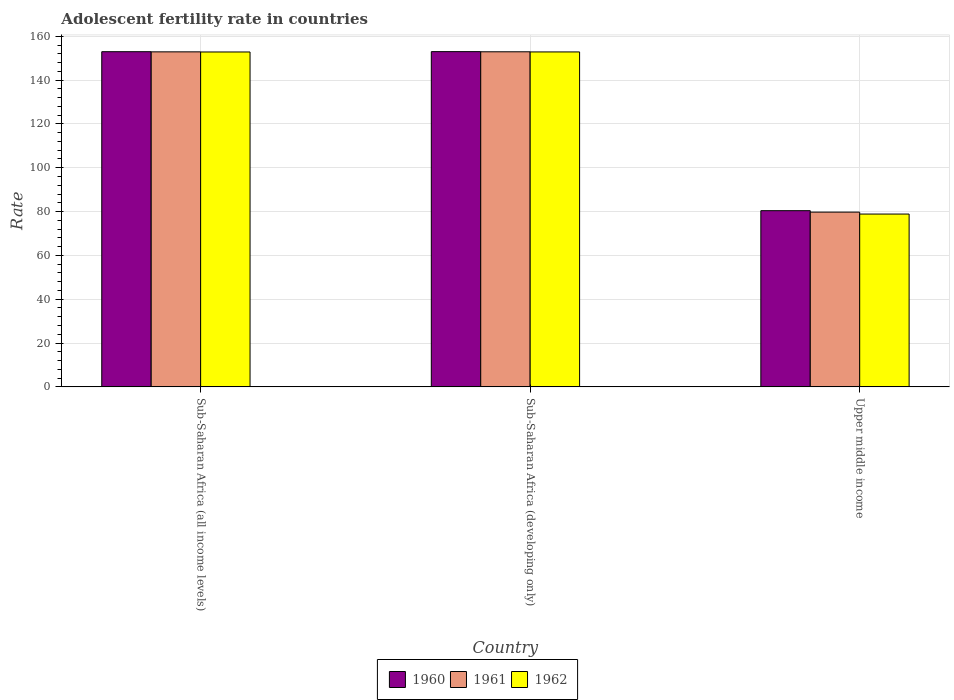Are the number of bars per tick equal to the number of legend labels?
Your answer should be very brief. Yes. Are the number of bars on each tick of the X-axis equal?
Your answer should be compact. Yes. How many bars are there on the 1st tick from the left?
Your answer should be compact. 3. What is the label of the 1st group of bars from the left?
Your answer should be compact. Sub-Saharan Africa (all income levels). What is the adolescent fertility rate in 1961 in Sub-Saharan Africa (all income levels)?
Provide a short and direct response. 152.9. Across all countries, what is the maximum adolescent fertility rate in 1960?
Keep it short and to the point. 152.99. Across all countries, what is the minimum adolescent fertility rate in 1961?
Your answer should be very brief. 79.75. In which country was the adolescent fertility rate in 1961 maximum?
Give a very brief answer. Sub-Saharan Africa (developing only). In which country was the adolescent fertility rate in 1962 minimum?
Provide a short and direct response. Upper middle income. What is the total adolescent fertility rate in 1962 in the graph?
Keep it short and to the point. 384.56. What is the difference between the adolescent fertility rate in 1960 in Sub-Saharan Africa (all income levels) and that in Sub-Saharan Africa (developing only)?
Provide a succinct answer. -0.03. What is the difference between the adolescent fertility rate in 1960 in Sub-Saharan Africa (all income levels) and the adolescent fertility rate in 1961 in Sub-Saharan Africa (developing only)?
Your response must be concise. 0.04. What is the average adolescent fertility rate in 1960 per country?
Give a very brief answer. 128.79. What is the difference between the adolescent fertility rate of/in 1961 and adolescent fertility rate of/in 1960 in Sub-Saharan Africa (developing only)?
Ensure brevity in your answer.  -0.07. In how many countries, is the adolescent fertility rate in 1961 greater than 100?
Ensure brevity in your answer.  2. What is the ratio of the adolescent fertility rate in 1961 in Sub-Saharan Africa (all income levels) to that in Upper middle income?
Offer a very short reply. 1.92. Is the adolescent fertility rate in 1962 in Sub-Saharan Africa (developing only) less than that in Upper middle income?
Keep it short and to the point. No. Is the difference between the adolescent fertility rate in 1961 in Sub-Saharan Africa (all income levels) and Sub-Saharan Africa (developing only) greater than the difference between the adolescent fertility rate in 1960 in Sub-Saharan Africa (all income levels) and Sub-Saharan Africa (developing only)?
Make the answer very short. Yes. What is the difference between the highest and the second highest adolescent fertility rate in 1960?
Offer a very short reply. 72.58. What is the difference between the highest and the lowest adolescent fertility rate in 1960?
Keep it short and to the point. 72.58. What does the 1st bar from the left in Sub-Saharan Africa (developing only) represents?
Make the answer very short. 1960. What does the 3rd bar from the right in Sub-Saharan Africa (developing only) represents?
Keep it short and to the point. 1960. What is the difference between two consecutive major ticks on the Y-axis?
Your response must be concise. 20. Are the values on the major ticks of Y-axis written in scientific E-notation?
Your response must be concise. No. Does the graph contain any zero values?
Ensure brevity in your answer.  No. Where does the legend appear in the graph?
Offer a terse response. Bottom center. How are the legend labels stacked?
Make the answer very short. Horizontal. What is the title of the graph?
Give a very brief answer. Adolescent fertility rate in countries. Does "1995" appear as one of the legend labels in the graph?
Your answer should be compact. No. What is the label or title of the X-axis?
Make the answer very short. Country. What is the label or title of the Y-axis?
Your response must be concise. Rate. What is the Rate of 1960 in Sub-Saharan Africa (all income levels)?
Provide a short and direct response. 152.96. What is the Rate in 1961 in Sub-Saharan Africa (all income levels)?
Your answer should be compact. 152.9. What is the Rate in 1962 in Sub-Saharan Africa (all income levels)?
Provide a short and direct response. 152.84. What is the Rate in 1960 in Sub-Saharan Africa (developing only)?
Your answer should be compact. 152.99. What is the Rate of 1961 in Sub-Saharan Africa (developing only)?
Provide a succinct answer. 152.93. What is the Rate of 1962 in Sub-Saharan Africa (developing only)?
Offer a terse response. 152.86. What is the Rate of 1960 in Upper middle income?
Give a very brief answer. 80.41. What is the Rate in 1961 in Upper middle income?
Your answer should be very brief. 79.75. What is the Rate in 1962 in Upper middle income?
Provide a short and direct response. 78.87. Across all countries, what is the maximum Rate of 1960?
Provide a succinct answer. 152.99. Across all countries, what is the maximum Rate of 1961?
Make the answer very short. 152.93. Across all countries, what is the maximum Rate in 1962?
Ensure brevity in your answer.  152.86. Across all countries, what is the minimum Rate of 1960?
Offer a terse response. 80.41. Across all countries, what is the minimum Rate in 1961?
Ensure brevity in your answer.  79.75. Across all countries, what is the minimum Rate in 1962?
Your answer should be compact. 78.87. What is the total Rate in 1960 in the graph?
Your answer should be compact. 386.37. What is the total Rate of 1961 in the graph?
Provide a succinct answer. 385.58. What is the total Rate of 1962 in the graph?
Your answer should be compact. 384.56. What is the difference between the Rate in 1960 in Sub-Saharan Africa (all income levels) and that in Sub-Saharan Africa (developing only)?
Your answer should be compact. -0.03. What is the difference between the Rate of 1961 in Sub-Saharan Africa (all income levels) and that in Sub-Saharan Africa (developing only)?
Give a very brief answer. -0.03. What is the difference between the Rate of 1962 in Sub-Saharan Africa (all income levels) and that in Sub-Saharan Africa (developing only)?
Make the answer very short. -0.03. What is the difference between the Rate of 1960 in Sub-Saharan Africa (all income levels) and that in Upper middle income?
Your answer should be compact. 72.55. What is the difference between the Rate of 1961 in Sub-Saharan Africa (all income levels) and that in Upper middle income?
Give a very brief answer. 73.14. What is the difference between the Rate of 1962 in Sub-Saharan Africa (all income levels) and that in Upper middle income?
Offer a very short reply. 73.97. What is the difference between the Rate in 1960 in Sub-Saharan Africa (developing only) and that in Upper middle income?
Provide a short and direct response. 72.58. What is the difference between the Rate in 1961 in Sub-Saharan Africa (developing only) and that in Upper middle income?
Offer a terse response. 73.17. What is the difference between the Rate in 1962 in Sub-Saharan Africa (developing only) and that in Upper middle income?
Give a very brief answer. 74. What is the difference between the Rate of 1960 in Sub-Saharan Africa (all income levels) and the Rate of 1961 in Sub-Saharan Africa (developing only)?
Provide a succinct answer. 0.04. What is the difference between the Rate of 1960 in Sub-Saharan Africa (all income levels) and the Rate of 1962 in Sub-Saharan Africa (developing only)?
Ensure brevity in your answer.  0.1. What is the difference between the Rate in 1961 in Sub-Saharan Africa (all income levels) and the Rate in 1962 in Sub-Saharan Africa (developing only)?
Ensure brevity in your answer.  0.04. What is the difference between the Rate in 1960 in Sub-Saharan Africa (all income levels) and the Rate in 1961 in Upper middle income?
Provide a short and direct response. 73.21. What is the difference between the Rate in 1960 in Sub-Saharan Africa (all income levels) and the Rate in 1962 in Upper middle income?
Keep it short and to the point. 74.1. What is the difference between the Rate of 1961 in Sub-Saharan Africa (all income levels) and the Rate of 1962 in Upper middle income?
Keep it short and to the point. 74.03. What is the difference between the Rate in 1960 in Sub-Saharan Africa (developing only) and the Rate in 1961 in Upper middle income?
Provide a short and direct response. 73.24. What is the difference between the Rate of 1960 in Sub-Saharan Africa (developing only) and the Rate of 1962 in Upper middle income?
Provide a succinct answer. 74.13. What is the difference between the Rate of 1961 in Sub-Saharan Africa (developing only) and the Rate of 1962 in Upper middle income?
Offer a terse response. 74.06. What is the average Rate in 1960 per country?
Your answer should be compact. 128.79. What is the average Rate in 1961 per country?
Offer a very short reply. 128.53. What is the average Rate of 1962 per country?
Offer a very short reply. 128.19. What is the difference between the Rate of 1960 and Rate of 1961 in Sub-Saharan Africa (all income levels)?
Your answer should be very brief. 0.07. What is the difference between the Rate of 1960 and Rate of 1962 in Sub-Saharan Africa (all income levels)?
Your answer should be very brief. 0.13. What is the difference between the Rate of 1961 and Rate of 1962 in Sub-Saharan Africa (all income levels)?
Your response must be concise. 0.06. What is the difference between the Rate in 1960 and Rate in 1961 in Sub-Saharan Africa (developing only)?
Your answer should be compact. 0.07. What is the difference between the Rate in 1960 and Rate in 1962 in Sub-Saharan Africa (developing only)?
Your answer should be compact. 0.13. What is the difference between the Rate of 1961 and Rate of 1962 in Sub-Saharan Africa (developing only)?
Your response must be concise. 0.06. What is the difference between the Rate in 1960 and Rate in 1961 in Upper middle income?
Provide a succinct answer. 0.66. What is the difference between the Rate in 1960 and Rate in 1962 in Upper middle income?
Provide a succinct answer. 1.54. What is the difference between the Rate in 1961 and Rate in 1962 in Upper middle income?
Offer a very short reply. 0.89. What is the ratio of the Rate of 1960 in Sub-Saharan Africa (all income levels) to that in Sub-Saharan Africa (developing only)?
Provide a succinct answer. 1. What is the ratio of the Rate in 1961 in Sub-Saharan Africa (all income levels) to that in Sub-Saharan Africa (developing only)?
Keep it short and to the point. 1. What is the ratio of the Rate of 1962 in Sub-Saharan Africa (all income levels) to that in Sub-Saharan Africa (developing only)?
Give a very brief answer. 1. What is the ratio of the Rate of 1960 in Sub-Saharan Africa (all income levels) to that in Upper middle income?
Provide a succinct answer. 1.9. What is the ratio of the Rate of 1961 in Sub-Saharan Africa (all income levels) to that in Upper middle income?
Provide a short and direct response. 1.92. What is the ratio of the Rate of 1962 in Sub-Saharan Africa (all income levels) to that in Upper middle income?
Keep it short and to the point. 1.94. What is the ratio of the Rate in 1960 in Sub-Saharan Africa (developing only) to that in Upper middle income?
Give a very brief answer. 1.9. What is the ratio of the Rate in 1961 in Sub-Saharan Africa (developing only) to that in Upper middle income?
Offer a very short reply. 1.92. What is the ratio of the Rate of 1962 in Sub-Saharan Africa (developing only) to that in Upper middle income?
Your answer should be compact. 1.94. What is the difference between the highest and the second highest Rate in 1960?
Offer a terse response. 0.03. What is the difference between the highest and the second highest Rate of 1961?
Give a very brief answer. 0.03. What is the difference between the highest and the second highest Rate in 1962?
Provide a short and direct response. 0.03. What is the difference between the highest and the lowest Rate of 1960?
Your response must be concise. 72.58. What is the difference between the highest and the lowest Rate of 1961?
Provide a succinct answer. 73.17. What is the difference between the highest and the lowest Rate of 1962?
Make the answer very short. 74. 